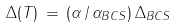<formula> <loc_0><loc_0><loc_500><loc_500>\Delta ( T ) \, = \, ( \alpha \, / \, \alpha _ { B C S } ) \, \Delta _ { B C S }</formula> 